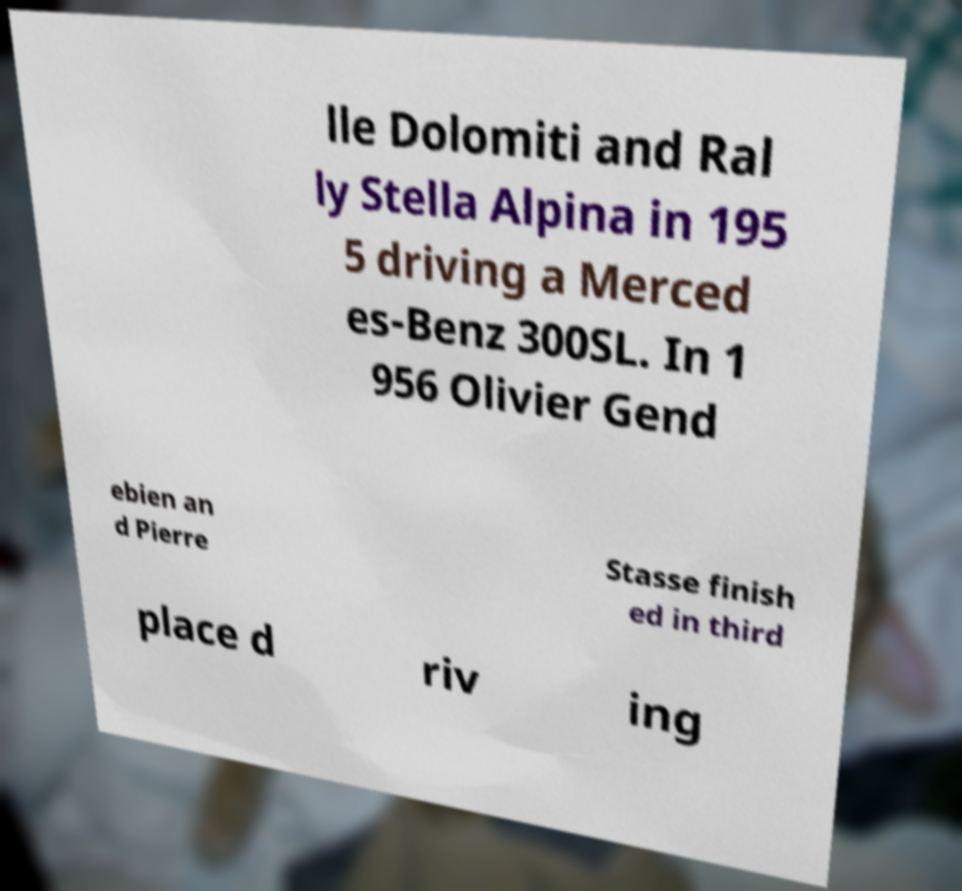I need the written content from this picture converted into text. Can you do that? lle Dolomiti and Ral ly Stella Alpina in 195 5 driving a Merced es-Benz 300SL. In 1 956 Olivier Gend ebien an d Pierre Stasse finish ed in third place d riv ing 